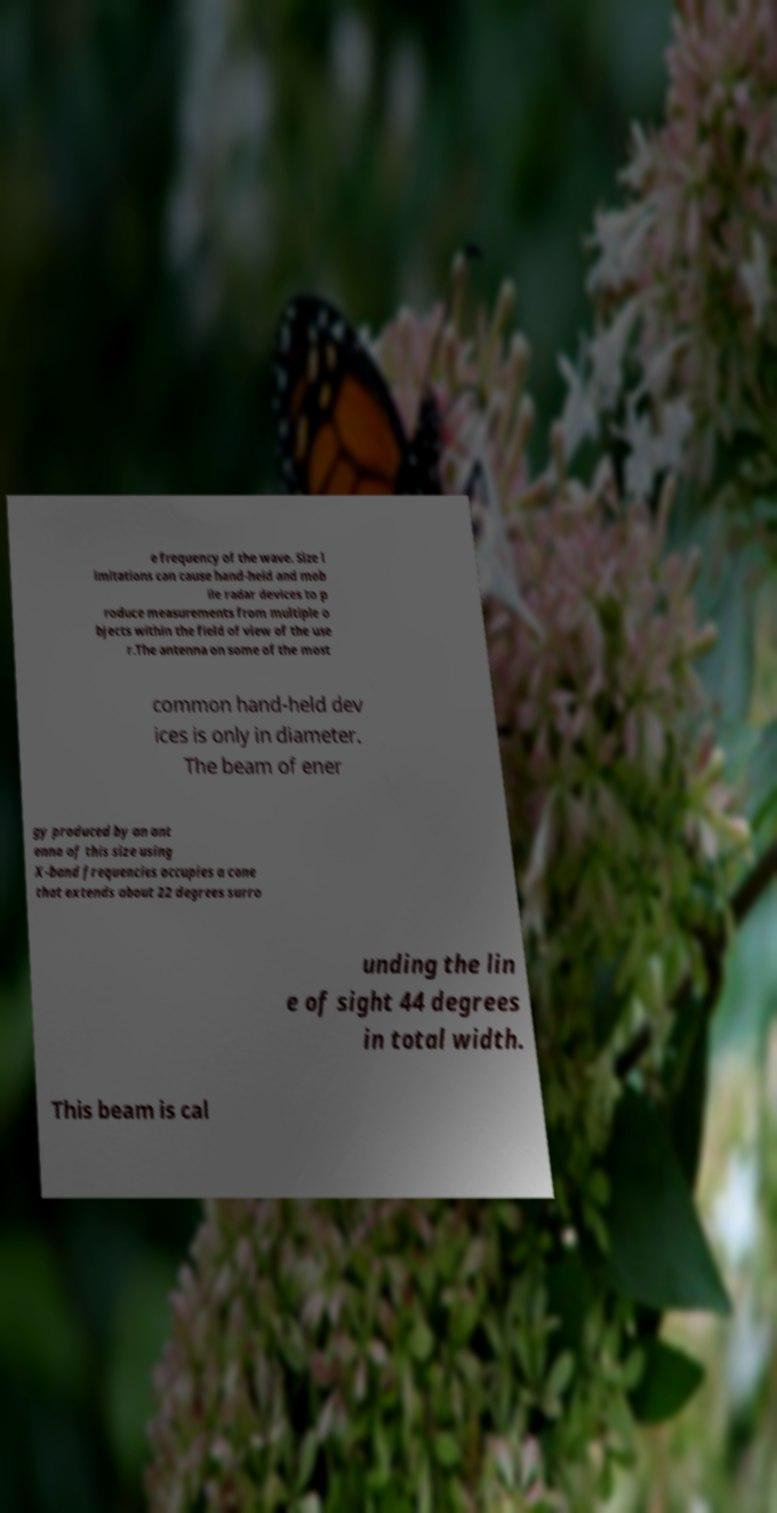For documentation purposes, I need the text within this image transcribed. Could you provide that? e frequency of the wave. Size l imitations can cause hand-held and mob ile radar devices to p roduce measurements from multiple o bjects within the field of view of the use r.The antenna on some of the most common hand-held dev ices is only in diameter. The beam of ener gy produced by an ant enna of this size using X-band frequencies occupies a cone that extends about 22 degrees surro unding the lin e of sight 44 degrees in total width. This beam is cal 